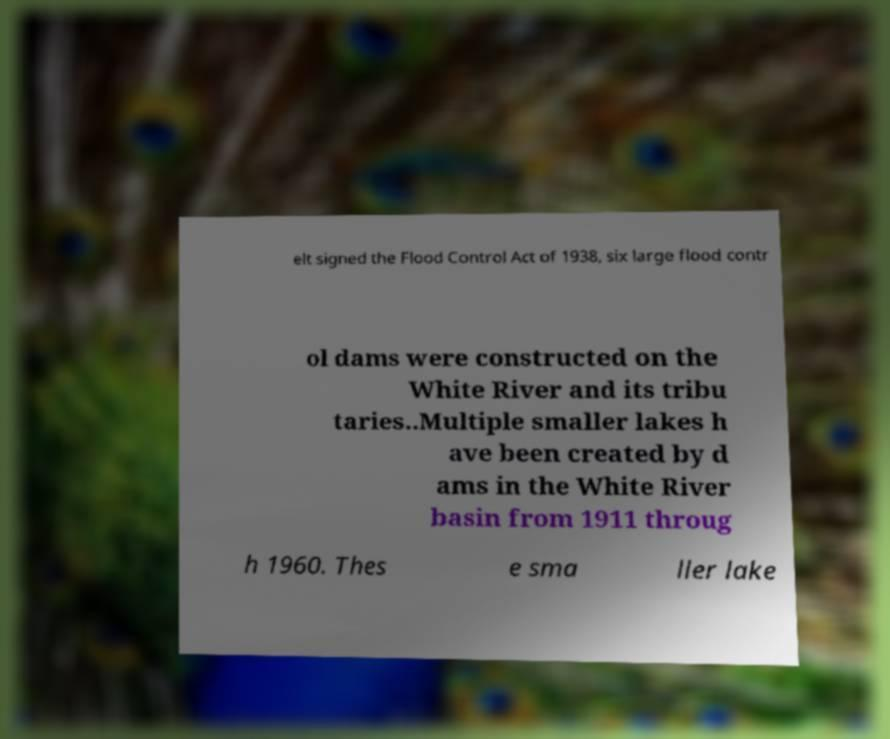Please read and relay the text visible in this image. What does it say? elt signed the Flood Control Act of 1938, six large flood contr ol dams were constructed on the White River and its tribu taries..Multiple smaller lakes h ave been created by d ams in the White River basin from 1911 throug h 1960. Thes e sma ller lake 